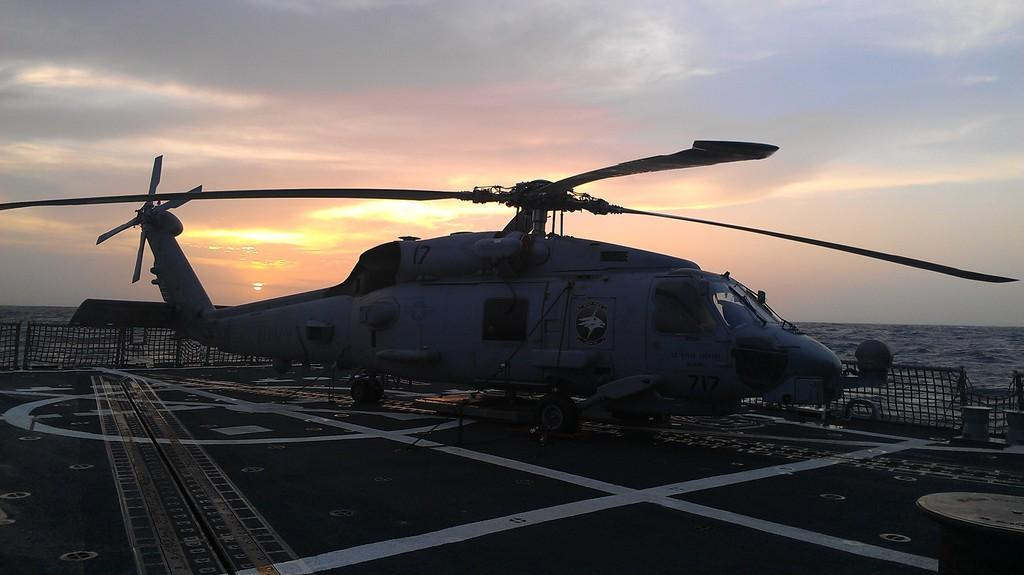What can be seen in the image that resembles lines? There are white lines in the image. What type of vehicle is present in the image? There is a helicopter in the image. What natural element is visible in the image? There is water visible in the image. What is written in the image? There is text written in the image. What can be seen in the background of the image? There are clouds and the sky visible in the background of the image. What type of underwear is being advertised in the image? There is no underwear or advertisement present in the image. Can you see any feathers floating in the water in the image? There are no feathers visible in the image. 